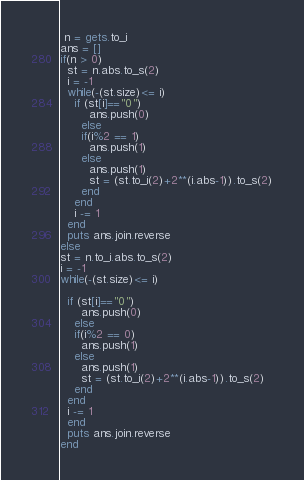<code> <loc_0><loc_0><loc_500><loc_500><_Ruby_> n = gets.to_i
ans = []
if(n > 0)
  st = n.abs.to_s(2)
  i = -1
  while(-(st.size)<= i)
    if (st[i]=="0")
        ans.push(0)
      else
      if(i%2 == 1)
        ans.push(1)
      else
        ans.push(1)
        st = (st.to_i(2)+2**(i.abs-1)).to_s(2)
      end
    end
    i -= 1
  end 
  puts ans.join.reverse
else
st = n.to_i.abs.to_s(2)
i = -1
while(-(st.size)<= i)
  
  if (st[i]=="0")
      ans.push(0)
    else
    if(i%2 == 0)
      ans.push(1)
    else
      ans.push(1)
      st = (st.to_i(2)+2**(i.abs-1)).to_s(2)
    end
  end
  i -= 1
  end 
  puts ans.join.reverse
end</code> 